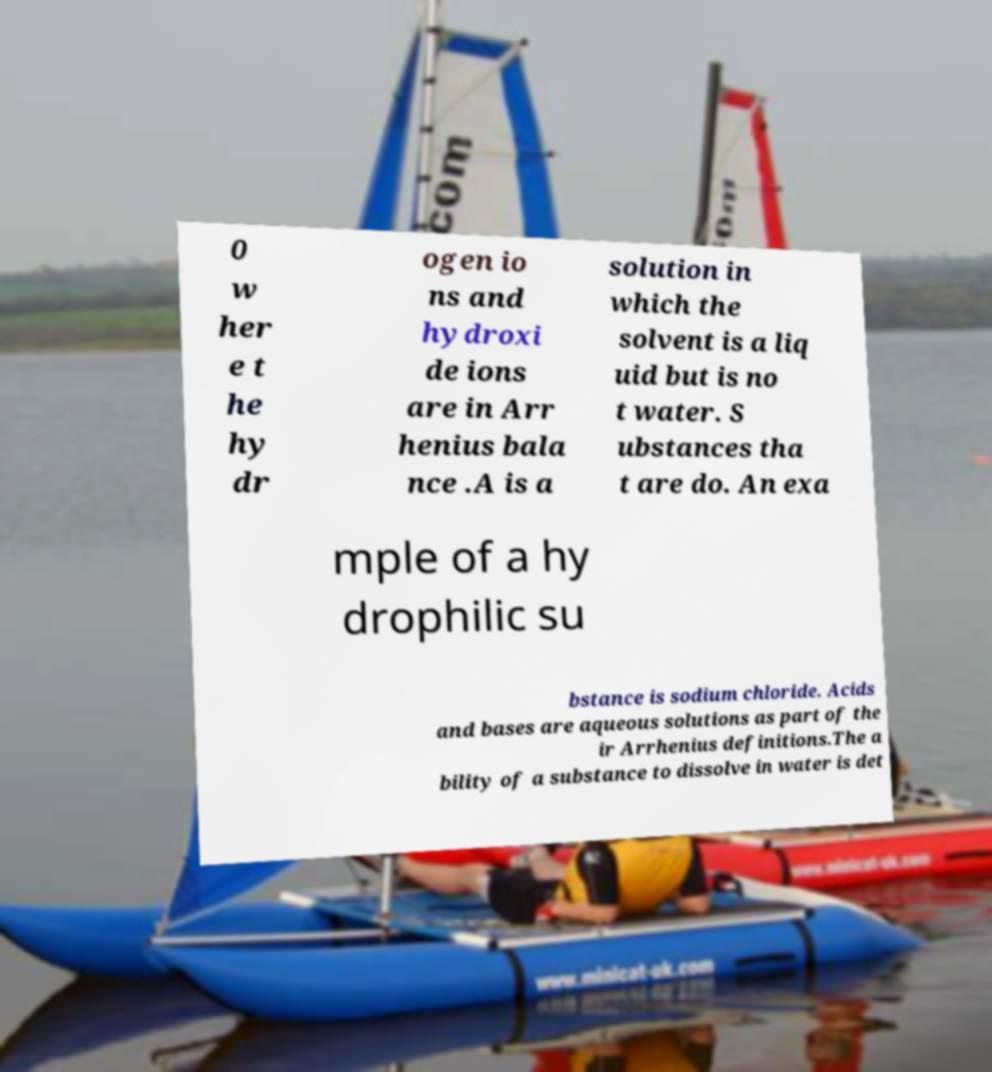Can you read and provide the text displayed in the image?This photo seems to have some interesting text. Can you extract and type it out for me? 0 w her e t he hy dr ogen io ns and hydroxi de ions are in Arr henius bala nce .A is a solution in which the solvent is a liq uid but is no t water. S ubstances tha t are do. An exa mple of a hy drophilic su bstance is sodium chloride. Acids and bases are aqueous solutions as part of the ir Arrhenius definitions.The a bility of a substance to dissolve in water is det 